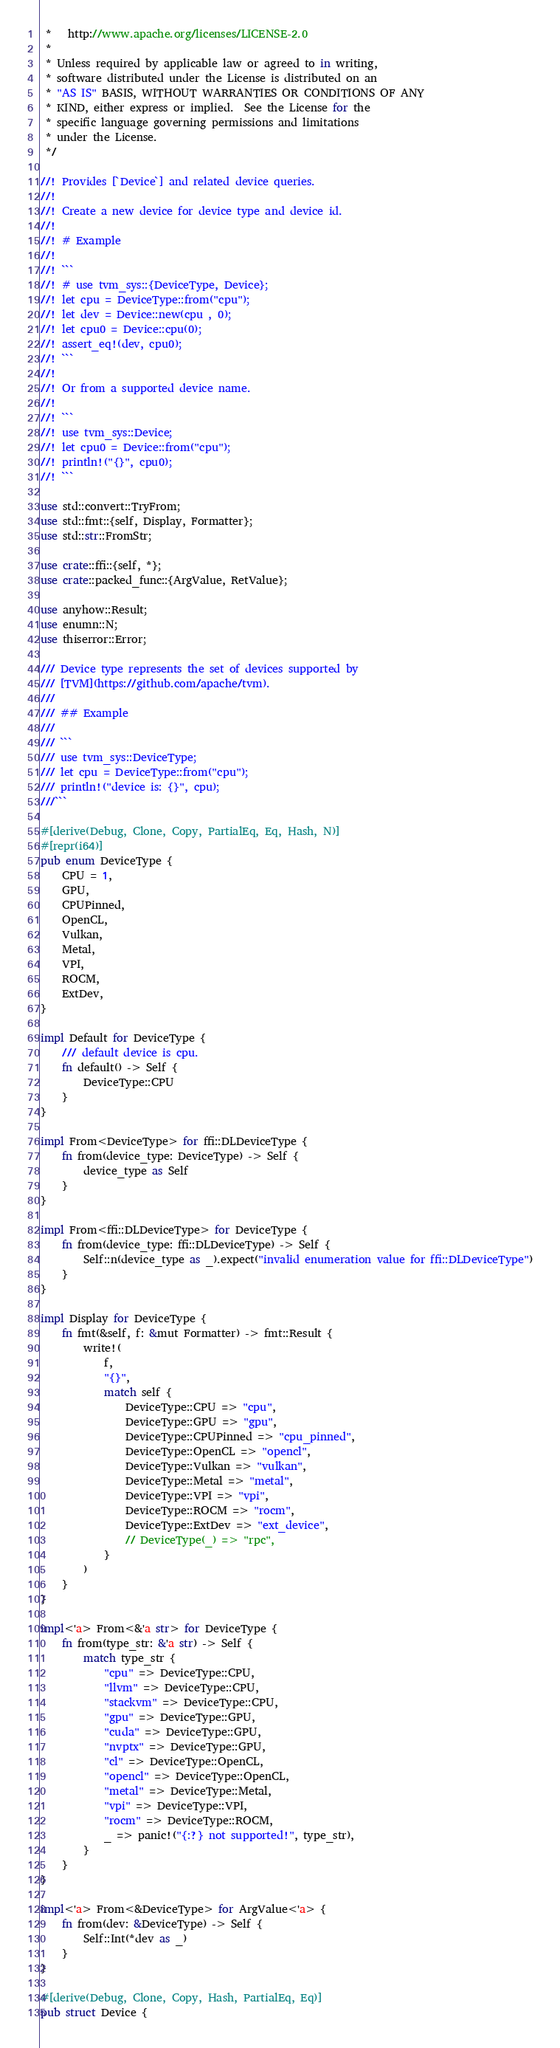Convert code to text. <code><loc_0><loc_0><loc_500><loc_500><_Rust_> *   http://www.apache.org/licenses/LICENSE-2.0
 *
 * Unless required by applicable law or agreed to in writing,
 * software distributed under the License is distributed on an
 * "AS IS" BASIS, WITHOUT WARRANTIES OR CONDITIONS OF ANY
 * KIND, either express or implied.  See the License for the
 * specific language governing permissions and limitations
 * under the License.
 */

//! Provides [`Device`] and related device queries.
//!
//! Create a new device for device type and device id.
//!
//! # Example
//!
//! ```
//! # use tvm_sys::{DeviceType, Device};
//! let cpu = DeviceType::from("cpu");
//! let dev = Device::new(cpu , 0);
//! let cpu0 = Device::cpu(0);
//! assert_eq!(dev, cpu0);
//! ```
//!
//! Or from a supported device name.
//!
//! ```
//! use tvm_sys::Device;
//! let cpu0 = Device::from("cpu");
//! println!("{}", cpu0);
//! ```

use std::convert::TryFrom;
use std::fmt::{self, Display, Formatter};
use std::str::FromStr;

use crate::ffi::{self, *};
use crate::packed_func::{ArgValue, RetValue};

use anyhow::Result;
use enumn::N;
use thiserror::Error;

/// Device type represents the set of devices supported by
/// [TVM](https://github.com/apache/tvm).
///
/// ## Example
///
/// ```
/// use tvm_sys::DeviceType;
/// let cpu = DeviceType::from("cpu");
/// println!("device is: {}", cpu);
///```

#[derive(Debug, Clone, Copy, PartialEq, Eq, Hash, N)]
#[repr(i64)]
pub enum DeviceType {
    CPU = 1,
    GPU,
    CPUPinned,
    OpenCL,
    Vulkan,
    Metal,
    VPI,
    ROCM,
    ExtDev,
}

impl Default for DeviceType {
    /// default device is cpu.
    fn default() -> Self {
        DeviceType::CPU
    }
}

impl From<DeviceType> for ffi::DLDeviceType {
    fn from(device_type: DeviceType) -> Self {
        device_type as Self
    }
}

impl From<ffi::DLDeviceType> for DeviceType {
    fn from(device_type: ffi::DLDeviceType) -> Self {
        Self::n(device_type as _).expect("invalid enumeration value for ffi::DLDeviceType")
    }
}

impl Display for DeviceType {
    fn fmt(&self, f: &mut Formatter) -> fmt::Result {
        write!(
            f,
            "{}",
            match self {
                DeviceType::CPU => "cpu",
                DeviceType::GPU => "gpu",
                DeviceType::CPUPinned => "cpu_pinned",
                DeviceType::OpenCL => "opencl",
                DeviceType::Vulkan => "vulkan",
                DeviceType::Metal => "metal",
                DeviceType::VPI => "vpi",
                DeviceType::ROCM => "rocm",
                DeviceType::ExtDev => "ext_device",
                // DeviceType(_) => "rpc",
            }
        )
    }
}

impl<'a> From<&'a str> for DeviceType {
    fn from(type_str: &'a str) -> Self {
        match type_str {
            "cpu" => DeviceType::CPU,
            "llvm" => DeviceType::CPU,
            "stackvm" => DeviceType::CPU,
            "gpu" => DeviceType::GPU,
            "cuda" => DeviceType::GPU,
            "nvptx" => DeviceType::GPU,
            "cl" => DeviceType::OpenCL,
            "opencl" => DeviceType::OpenCL,
            "metal" => DeviceType::Metal,
            "vpi" => DeviceType::VPI,
            "rocm" => DeviceType::ROCM,
            _ => panic!("{:?} not supported!", type_str),
        }
    }
}

impl<'a> From<&DeviceType> for ArgValue<'a> {
    fn from(dev: &DeviceType) -> Self {
        Self::Int(*dev as _)
    }
}

#[derive(Debug, Clone, Copy, Hash, PartialEq, Eq)]
pub struct Device {</code> 